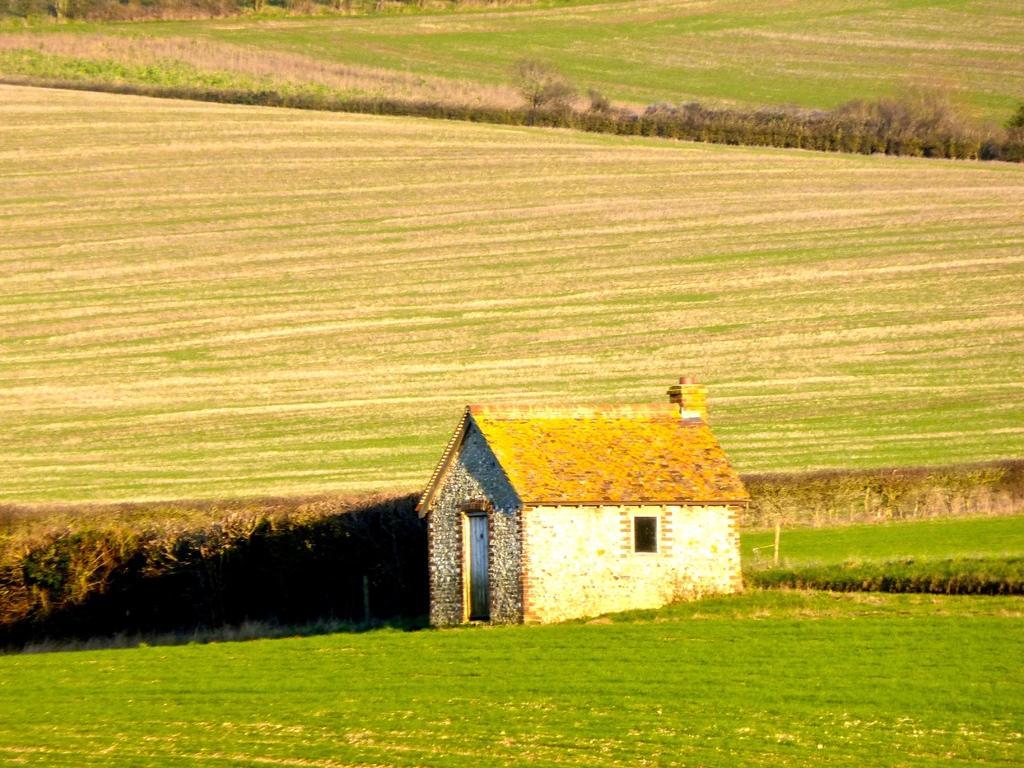How would you summarize this image in a sentence or two? In this image I can see the house. In the background I can see the grass and plants in green color. 